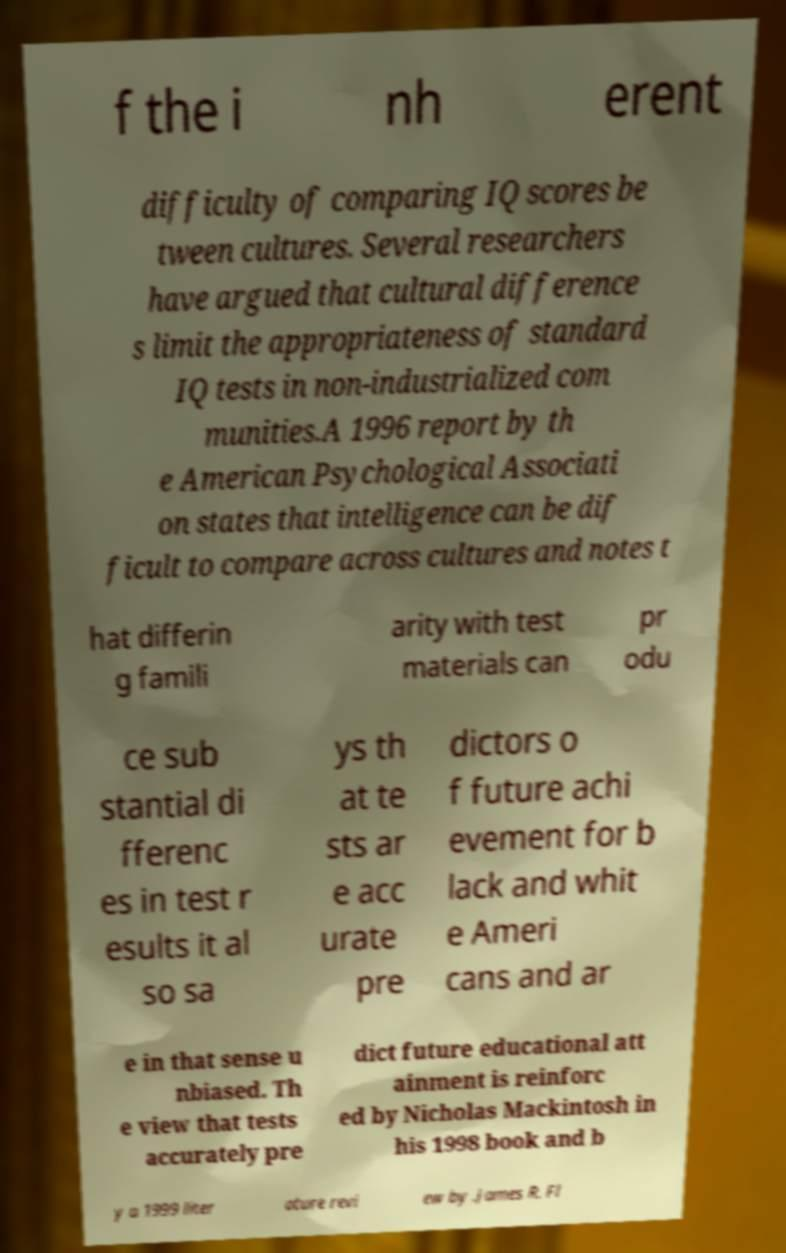What messages or text are displayed in this image? I need them in a readable, typed format. f the i nh erent difficulty of comparing IQ scores be tween cultures. Several researchers have argued that cultural difference s limit the appropriateness of standard IQ tests in non-industrialized com munities.A 1996 report by th e American Psychological Associati on states that intelligence can be dif ficult to compare across cultures and notes t hat differin g famili arity with test materials can pr odu ce sub stantial di fferenc es in test r esults it al so sa ys th at te sts ar e acc urate pre dictors o f future achi evement for b lack and whit e Ameri cans and ar e in that sense u nbiased. Th e view that tests accurately pre dict future educational att ainment is reinforc ed by Nicholas Mackintosh in his 1998 book and b y a 1999 liter ature revi ew by .James R. Fl 